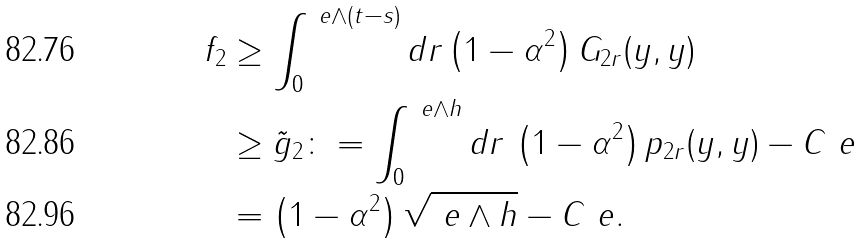Convert formula to latex. <formula><loc_0><loc_0><loc_500><loc_500>f _ { 2 } & \geq \int _ { 0 } ^ { \ e \wedge ( t - s ) } d r \left ( 1 - \alpha ^ { 2 } \right ) G _ { 2 r } ( y , y ) \\ & \geq \tilde { g } _ { 2 } \colon = \int _ { 0 } ^ { \ e \wedge h } d r \, \left ( 1 - \alpha ^ { 2 } \right ) p _ { 2 r } ( y , y ) - C \ e \\ & = \left ( 1 - \alpha ^ { 2 } \right ) \sqrt { \ e \wedge h } - C \ e .</formula> 